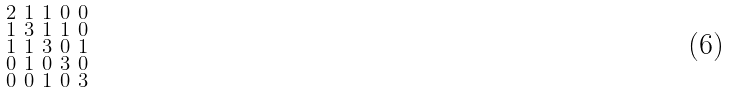Convert formula to latex. <formula><loc_0><loc_0><loc_500><loc_500>\begin{smallmatrix} 2 & 1 & 1 & 0 & 0 \\ 1 & 3 & 1 & 1 & 0 \\ 1 & 1 & 3 & 0 & 1 \\ 0 & 1 & 0 & 3 & 0 \\ 0 & 0 & 1 & 0 & 3 \end{smallmatrix}</formula> 